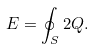Convert formula to latex. <formula><loc_0><loc_0><loc_500><loc_500>E = \oint _ { S } 2 Q .</formula> 